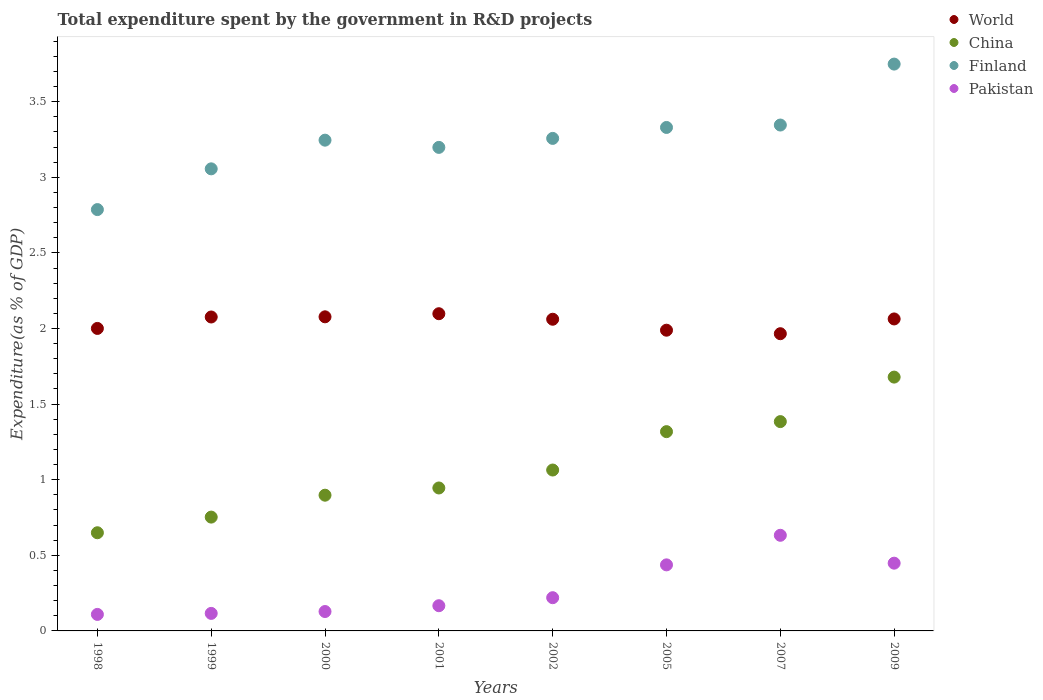How many different coloured dotlines are there?
Give a very brief answer. 4. Is the number of dotlines equal to the number of legend labels?
Provide a succinct answer. Yes. What is the total expenditure spent by the government in R&D projects in World in 2009?
Provide a short and direct response. 2.06. Across all years, what is the maximum total expenditure spent by the government in R&D projects in Pakistan?
Offer a terse response. 0.63. Across all years, what is the minimum total expenditure spent by the government in R&D projects in Pakistan?
Your answer should be very brief. 0.11. In which year was the total expenditure spent by the government in R&D projects in China maximum?
Offer a terse response. 2009. What is the total total expenditure spent by the government in R&D projects in Finland in the graph?
Provide a short and direct response. 25.97. What is the difference between the total expenditure spent by the government in R&D projects in Finland in 1999 and that in 2001?
Your answer should be very brief. -0.14. What is the difference between the total expenditure spent by the government in R&D projects in World in 1999 and the total expenditure spent by the government in R&D projects in Pakistan in 2005?
Offer a very short reply. 1.64. What is the average total expenditure spent by the government in R&D projects in Finland per year?
Provide a short and direct response. 3.25. In the year 2001, what is the difference between the total expenditure spent by the government in R&D projects in World and total expenditure spent by the government in R&D projects in China?
Your answer should be compact. 1.15. In how many years, is the total expenditure spent by the government in R&D projects in Pakistan greater than 0.1 %?
Keep it short and to the point. 8. What is the ratio of the total expenditure spent by the government in R&D projects in World in 2007 to that in 2009?
Your answer should be very brief. 0.95. What is the difference between the highest and the second highest total expenditure spent by the government in R&D projects in Finland?
Provide a succinct answer. 0.4. What is the difference between the highest and the lowest total expenditure spent by the government in R&D projects in Pakistan?
Offer a terse response. 0.52. In how many years, is the total expenditure spent by the government in R&D projects in Finland greater than the average total expenditure spent by the government in R&D projects in Finland taken over all years?
Offer a very short reply. 4. Is the sum of the total expenditure spent by the government in R&D projects in Pakistan in 1998 and 1999 greater than the maximum total expenditure spent by the government in R&D projects in Finland across all years?
Offer a very short reply. No. Is it the case that in every year, the sum of the total expenditure spent by the government in R&D projects in China and total expenditure spent by the government in R&D projects in Finland  is greater than the sum of total expenditure spent by the government in R&D projects in Pakistan and total expenditure spent by the government in R&D projects in World?
Keep it short and to the point. Yes. Is the total expenditure spent by the government in R&D projects in Finland strictly greater than the total expenditure spent by the government in R&D projects in World over the years?
Make the answer very short. Yes. Is the total expenditure spent by the government in R&D projects in World strictly less than the total expenditure spent by the government in R&D projects in China over the years?
Offer a very short reply. No. Are the values on the major ticks of Y-axis written in scientific E-notation?
Your response must be concise. No. Does the graph contain grids?
Your answer should be very brief. No. Where does the legend appear in the graph?
Your answer should be compact. Top right. How many legend labels are there?
Your response must be concise. 4. What is the title of the graph?
Offer a terse response. Total expenditure spent by the government in R&D projects. Does "Tunisia" appear as one of the legend labels in the graph?
Your answer should be compact. No. What is the label or title of the X-axis?
Offer a very short reply. Years. What is the label or title of the Y-axis?
Offer a very short reply. Expenditure(as % of GDP). What is the Expenditure(as % of GDP) of World in 1998?
Make the answer very short. 2. What is the Expenditure(as % of GDP) of China in 1998?
Your answer should be very brief. 0.65. What is the Expenditure(as % of GDP) in Finland in 1998?
Your answer should be compact. 2.79. What is the Expenditure(as % of GDP) of Pakistan in 1998?
Offer a very short reply. 0.11. What is the Expenditure(as % of GDP) in World in 1999?
Your answer should be very brief. 2.08. What is the Expenditure(as % of GDP) in China in 1999?
Your response must be concise. 0.75. What is the Expenditure(as % of GDP) of Finland in 1999?
Provide a short and direct response. 3.06. What is the Expenditure(as % of GDP) of Pakistan in 1999?
Provide a succinct answer. 0.12. What is the Expenditure(as % of GDP) of World in 2000?
Keep it short and to the point. 2.08. What is the Expenditure(as % of GDP) of China in 2000?
Keep it short and to the point. 0.9. What is the Expenditure(as % of GDP) of Finland in 2000?
Your answer should be very brief. 3.25. What is the Expenditure(as % of GDP) in Pakistan in 2000?
Ensure brevity in your answer.  0.13. What is the Expenditure(as % of GDP) in World in 2001?
Give a very brief answer. 2.1. What is the Expenditure(as % of GDP) in China in 2001?
Give a very brief answer. 0.95. What is the Expenditure(as % of GDP) in Finland in 2001?
Give a very brief answer. 3.2. What is the Expenditure(as % of GDP) in Pakistan in 2001?
Make the answer very short. 0.17. What is the Expenditure(as % of GDP) of World in 2002?
Keep it short and to the point. 2.06. What is the Expenditure(as % of GDP) in China in 2002?
Ensure brevity in your answer.  1.06. What is the Expenditure(as % of GDP) of Finland in 2002?
Ensure brevity in your answer.  3.26. What is the Expenditure(as % of GDP) of Pakistan in 2002?
Make the answer very short. 0.22. What is the Expenditure(as % of GDP) in World in 2005?
Provide a short and direct response. 1.99. What is the Expenditure(as % of GDP) of China in 2005?
Make the answer very short. 1.32. What is the Expenditure(as % of GDP) in Finland in 2005?
Ensure brevity in your answer.  3.33. What is the Expenditure(as % of GDP) in Pakistan in 2005?
Your answer should be very brief. 0.44. What is the Expenditure(as % of GDP) of World in 2007?
Your answer should be very brief. 1.97. What is the Expenditure(as % of GDP) in China in 2007?
Give a very brief answer. 1.38. What is the Expenditure(as % of GDP) of Finland in 2007?
Make the answer very short. 3.35. What is the Expenditure(as % of GDP) of Pakistan in 2007?
Offer a very short reply. 0.63. What is the Expenditure(as % of GDP) in World in 2009?
Offer a very short reply. 2.06. What is the Expenditure(as % of GDP) in China in 2009?
Offer a terse response. 1.68. What is the Expenditure(as % of GDP) in Finland in 2009?
Your answer should be compact. 3.75. What is the Expenditure(as % of GDP) in Pakistan in 2009?
Offer a very short reply. 0.45. Across all years, what is the maximum Expenditure(as % of GDP) in World?
Your response must be concise. 2.1. Across all years, what is the maximum Expenditure(as % of GDP) in China?
Make the answer very short. 1.68. Across all years, what is the maximum Expenditure(as % of GDP) in Finland?
Your answer should be compact. 3.75. Across all years, what is the maximum Expenditure(as % of GDP) of Pakistan?
Offer a very short reply. 0.63. Across all years, what is the minimum Expenditure(as % of GDP) in World?
Your answer should be very brief. 1.97. Across all years, what is the minimum Expenditure(as % of GDP) of China?
Make the answer very short. 0.65. Across all years, what is the minimum Expenditure(as % of GDP) in Finland?
Your response must be concise. 2.79. Across all years, what is the minimum Expenditure(as % of GDP) in Pakistan?
Provide a succinct answer. 0.11. What is the total Expenditure(as % of GDP) in World in the graph?
Your answer should be very brief. 16.33. What is the total Expenditure(as % of GDP) of China in the graph?
Give a very brief answer. 8.69. What is the total Expenditure(as % of GDP) of Finland in the graph?
Make the answer very short. 25.97. What is the total Expenditure(as % of GDP) in Pakistan in the graph?
Keep it short and to the point. 2.26. What is the difference between the Expenditure(as % of GDP) in World in 1998 and that in 1999?
Provide a short and direct response. -0.08. What is the difference between the Expenditure(as % of GDP) in China in 1998 and that in 1999?
Give a very brief answer. -0.1. What is the difference between the Expenditure(as % of GDP) in Finland in 1998 and that in 1999?
Make the answer very short. -0.27. What is the difference between the Expenditure(as % of GDP) in Pakistan in 1998 and that in 1999?
Your answer should be compact. -0.01. What is the difference between the Expenditure(as % of GDP) of World in 1998 and that in 2000?
Ensure brevity in your answer.  -0.08. What is the difference between the Expenditure(as % of GDP) of China in 1998 and that in 2000?
Provide a succinct answer. -0.25. What is the difference between the Expenditure(as % of GDP) of Finland in 1998 and that in 2000?
Your response must be concise. -0.46. What is the difference between the Expenditure(as % of GDP) in Pakistan in 1998 and that in 2000?
Give a very brief answer. -0.02. What is the difference between the Expenditure(as % of GDP) in World in 1998 and that in 2001?
Your answer should be very brief. -0.1. What is the difference between the Expenditure(as % of GDP) of China in 1998 and that in 2001?
Keep it short and to the point. -0.3. What is the difference between the Expenditure(as % of GDP) in Finland in 1998 and that in 2001?
Provide a succinct answer. -0.41. What is the difference between the Expenditure(as % of GDP) in Pakistan in 1998 and that in 2001?
Ensure brevity in your answer.  -0.06. What is the difference between the Expenditure(as % of GDP) of World in 1998 and that in 2002?
Your answer should be compact. -0.06. What is the difference between the Expenditure(as % of GDP) in China in 1998 and that in 2002?
Ensure brevity in your answer.  -0.41. What is the difference between the Expenditure(as % of GDP) in Finland in 1998 and that in 2002?
Make the answer very short. -0.47. What is the difference between the Expenditure(as % of GDP) in Pakistan in 1998 and that in 2002?
Offer a terse response. -0.11. What is the difference between the Expenditure(as % of GDP) in World in 1998 and that in 2005?
Your answer should be compact. 0.01. What is the difference between the Expenditure(as % of GDP) of China in 1998 and that in 2005?
Your answer should be very brief. -0.67. What is the difference between the Expenditure(as % of GDP) in Finland in 1998 and that in 2005?
Offer a terse response. -0.54. What is the difference between the Expenditure(as % of GDP) of Pakistan in 1998 and that in 2005?
Your answer should be compact. -0.33. What is the difference between the Expenditure(as % of GDP) in World in 1998 and that in 2007?
Provide a succinct answer. 0.03. What is the difference between the Expenditure(as % of GDP) of China in 1998 and that in 2007?
Provide a short and direct response. -0.74. What is the difference between the Expenditure(as % of GDP) of Finland in 1998 and that in 2007?
Your response must be concise. -0.56. What is the difference between the Expenditure(as % of GDP) of Pakistan in 1998 and that in 2007?
Your response must be concise. -0.52. What is the difference between the Expenditure(as % of GDP) in World in 1998 and that in 2009?
Give a very brief answer. -0.06. What is the difference between the Expenditure(as % of GDP) of China in 1998 and that in 2009?
Provide a succinct answer. -1.03. What is the difference between the Expenditure(as % of GDP) in Finland in 1998 and that in 2009?
Your answer should be very brief. -0.96. What is the difference between the Expenditure(as % of GDP) of Pakistan in 1998 and that in 2009?
Offer a terse response. -0.34. What is the difference between the Expenditure(as % of GDP) of World in 1999 and that in 2000?
Ensure brevity in your answer.  -0. What is the difference between the Expenditure(as % of GDP) in China in 1999 and that in 2000?
Your response must be concise. -0.14. What is the difference between the Expenditure(as % of GDP) in Finland in 1999 and that in 2000?
Make the answer very short. -0.19. What is the difference between the Expenditure(as % of GDP) in Pakistan in 1999 and that in 2000?
Keep it short and to the point. -0.01. What is the difference between the Expenditure(as % of GDP) in World in 1999 and that in 2001?
Ensure brevity in your answer.  -0.02. What is the difference between the Expenditure(as % of GDP) in China in 1999 and that in 2001?
Make the answer very short. -0.19. What is the difference between the Expenditure(as % of GDP) in Finland in 1999 and that in 2001?
Make the answer very short. -0.14. What is the difference between the Expenditure(as % of GDP) of Pakistan in 1999 and that in 2001?
Provide a succinct answer. -0.05. What is the difference between the Expenditure(as % of GDP) in World in 1999 and that in 2002?
Make the answer very short. 0.01. What is the difference between the Expenditure(as % of GDP) of China in 1999 and that in 2002?
Give a very brief answer. -0.31. What is the difference between the Expenditure(as % of GDP) in Finland in 1999 and that in 2002?
Give a very brief answer. -0.2. What is the difference between the Expenditure(as % of GDP) of Pakistan in 1999 and that in 2002?
Keep it short and to the point. -0.1. What is the difference between the Expenditure(as % of GDP) in World in 1999 and that in 2005?
Your answer should be very brief. 0.09. What is the difference between the Expenditure(as % of GDP) of China in 1999 and that in 2005?
Your answer should be compact. -0.57. What is the difference between the Expenditure(as % of GDP) in Finland in 1999 and that in 2005?
Provide a short and direct response. -0.27. What is the difference between the Expenditure(as % of GDP) in Pakistan in 1999 and that in 2005?
Ensure brevity in your answer.  -0.32. What is the difference between the Expenditure(as % of GDP) of World in 1999 and that in 2007?
Keep it short and to the point. 0.11. What is the difference between the Expenditure(as % of GDP) of China in 1999 and that in 2007?
Provide a short and direct response. -0.63. What is the difference between the Expenditure(as % of GDP) in Finland in 1999 and that in 2007?
Keep it short and to the point. -0.29. What is the difference between the Expenditure(as % of GDP) of Pakistan in 1999 and that in 2007?
Offer a very short reply. -0.52. What is the difference between the Expenditure(as % of GDP) in World in 1999 and that in 2009?
Offer a terse response. 0.01. What is the difference between the Expenditure(as % of GDP) in China in 1999 and that in 2009?
Your answer should be compact. -0.93. What is the difference between the Expenditure(as % of GDP) of Finland in 1999 and that in 2009?
Your answer should be very brief. -0.69. What is the difference between the Expenditure(as % of GDP) of Pakistan in 1999 and that in 2009?
Offer a very short reply. -0.33. What is the difference between the Expenditure(as % of GDP) in World in 2000 and that in 2001?
Offer a terse response. -0.02. What is the difference between the Expenditure(as % of GDP) of China in 2000 and that in 2001?
Your answer should be compact. -0.05. What is the difference between the Expenditure(as % of GDP) of Finland in 2000 and that in 2001?
Keep it short and to the point. 0.05. What is the difference between the Expenditure(as % of GDP) in Pakistan in 2000 and that in 2001?
Your answer should be compact. -0.04. What is the difference between the Expenditure(as % of GDP) in World in 2000 and that in 2002?
Keep it short and to the point. 0.02. What is the difference between the Expenditure(as % of GDP) of China in 2000 and that in 2002?
Offer a terse response. -0.17. What is the difference between the Expenditure(as % of GDP) in Finland in 2000 and that in 2002?
Keep it short and to the point. -0.01. What is the difference between the Expenditure(as % of GDP) of Pakistan in 2000 and that in 2002?
Your answer should be very brief. -0.09. What is the difference between the Expenditure(as % of GDP) in World in 2000 and that in 2005?
Ensure brevity in your answer.  0.09. What is the difference between the Expenditure(as % of GDP) in China in 2000 and that in 2005?
Give a very brief answer. -0.42. What is the difference between the Expenditure(as % of GDP) in Finland in 2000 and that in 2005?
Ensure brevity in your answer.  -0.08. What is the difference between the Expenditure(as % of GDP) of Pakistan in 2000 and that in 2005?
Your answer should be very brief. -0.31. What is the difference between the Expenditure(as % of GDP) in World in 2000 and that in 2007?
Offer a very short reply. 0.11. What is the difference between the Expenditure(as % of GDP) of China in 2000 and that in 2007?
Your answer should be very brief. -0.49. What is the difference between the Expenditure(as % of GDP) of Finland in 2000 and that in 2007?
Your answer should be very brief. -0.1. What is the difference between the Expenditure(as % of GDP) in Pakistan in 2000 and that in 2007?
Provide a succinct answer. -0.5. What is the difference between the Expenditure(as % of GDP) in World in 2000 and that in 2009?
Provide a short and direct response. 0.01. What is the difference between the Expenditure(as % of GDP) of China in 2000 and that in 2009?
Your answer should be very brief. -0.78. What is the difference between the Expenditure(as % of GDP) of Finland in 2000 and that in 2009?
Give a very brief answer. -0.5. What is the difference between the Expenditure(as % of GDP) in Pakistan in 2000 and that in 2009?
Your answer should be compact. -0.32. What is the difference between the Expenditure(as % of GDP) of World in 2001 and that in 2002?
Ensure brevity in your answer.  0.04. What is the difference between the Expenditure(as % of GDP) of China in 2001 and that in 2002?
Offer a very short reply. -0.12. What is the difference between the Expenditure(as % of GDP) of Finland in 2001 and that in 2002?
Offer a very short reply. -0.06. What is the difference between the Expenditure(as % of GDP) in Pakistan in 2001 and that in 2002?
Ensure brevity in your answer.  -0.05. What is the difference between the Expenditure(as % of GDP) of World in 2001 and that in 2005?
Ensure brevity in your answer.  0.11. What is the difference between the Expenditure(as % of GDP) in China in 2001 and that in 2005?
Keep it short and to the point. -0.37. What is the difference between the Expenditure(as % of GDP) in Finland in 2001 and that in 2005?
Your answer should be very brief. -0.13. What is the difference between the Expenditure(as % of GDP) in Pakistan in 2001 and that in 2005?
Provide a succinct answer. -0.27. What is the difference between the Expenditure(as % of GDP) of World in 2001 and that in 2007?
Your response must be concise. 0.13. What is the difference between the Expenditure(as % of GDP) in China in 2001 and that in 2007?
Offer a very short reply. -0.44. What is the difference between the Expenditure(as % of GDP) in Finland in 2001 and that in 2007?
Make the answer very short. -0.15. What is the difference between the Expenditure(as % of GDP) of Pakistan in 2001 and that in 2007?
Keep it short and to the point. -0.47. What is the difference between the Expenditure(as % of GDP) in World in 2001 and that in 2009?
Make the answer very short. 0.03. What is the difference between the Expenditure(as % of GDP) in China in 2001 and that in 2009?
Provide a short and direct response. -0.73. What is the difference between the Expenditure(as % of GDP) of Finland in 2001 and that in 2009?
Keep it short and to the point. -0.55. What is the difference between the Expenditure(as % of GDP) of Pakistan in 2001 and that in 2009?
Your answer should be very brief. -0.28. What is the difference between the Expenditure(as % of GDP) in World in 2002 and that in 2005?
Make the answer very short. 0.07. What is the difference between the Expenditure(as % of GDP) of China in 2002 and that in 2005?
Keep it short and to the point. -0.25. What is the difference between the Expenditure(as % of GDP) of Finland in 2002 and that in 2005?
Provide a short and direct response. -0.07. What is the difference between the Expenditure(as % of GDP) of Pakistan in 2002 and that in 2005?
Ensure brevity in your answer.  -0.22. What is the difference between the Expenditure(as % of GDP) of World in 2002 and that in 2007?
Your answer should be compact. 0.1. What is the difference between the Expenditure(as % of GDP) of China in 2002 and that in 2007?
Offer a very short reply. -0.32. What is the difference between the Expenditure(as % of GDP) in Finland in 2002 and that in 2007?
Offer a very short reply. -0.09. What is the difference between the Expenditure(as % of GDP) of Pakistan in 2002 and that in 2007?
Make the answer very short. -0.41. What is the difference between the Expenditure(as % of GDP) of World in 2002 and that in 2009?
Offer a very short reply. -0. What is the difference between the Expenditure(as % of GDP) of China in 2002 and that in 2009?
Your answer should be compact. -0.61. What is the difference between the Expenditure(as % of GDP) in Finland in 2002 and that in 2009?
Ensure brevity in your answer.  -0.49. What is the difference between the Expenditure(as % of GDP) in Pakistan in 2002 and that in 2009?
Offer a very short reply. -0.23. What is the difference between the Expenditure(as % of GDP) in World in 2005 and that in 2007?
Your answer should be compact. 0.02. What is the difference between the Expenditure(as % of GDP) of China in 2005 and that in 2007?
Keep it short and to the point. -0.07. What is the difference between the Expenditure(as % of GDP) in Finland in 2005 and that in 2007?
Ensure brevity in your answer.  -0.02. What is the difference between the Expenditure(as % of GDP) in Pakistan in 2005 and that in 2007?
Give a very brief answer. -0.2. What is the difference between the Expenditure(as % of GDP) of World in 2005 and that in 2009?
Give a very brief answer. -0.07. What is the difference between the Expenditure(as % of GDP) in China in 2005 and that in 2009?
Keep it short and to the point. -0.36. What is the difference between the Expenditure(as % of GDP) in Finland in 2005 and that in 2009?
Offer a terse response. -0.42. What is the difference between the Expenditure(as % of GDP) of Pakistan in 2005 and that in 2009?
Make the answer very short. -0.01. What is the difference between the Expenditure(as % of GDP) in World in 2007 and that in 2009?
Provide a short and direct response. -0.1. What is the difference between the Expenditure(as % of GDP) of China in 2007 and that in 2009?
Provide a short and direct response. -0.29. What is the difference between the Expenditure(as % of GDP) in Finland in 2007 and that in 2009?
Offer a very short reply. -0.4. What is the difference between the Expenditure(as % of GDP) of Pakistan in 2007 and that in 2009?
Give a very brief answer. 0.18. What is the difference between the Expenditure(as % of GDP) of World in 1998 and the Expenditure(as % of GDP) of China in 1999?
Provide a succinct answer. 1.25. What is the difference between the Expenditure(as % of GDP) of World in 1998 and the Expenditure(as % of GDP) of Finland in 1999?
Keep it short and to the point. -1.06. What is the difference between the Expenditure(as % of GDP) of World in 1998 and the Expenditure(as % of GDP) of Pakistan in 1999?
Provide a succinct answer. 1.88. What is the difference between the Expenditure(as % of GDP) of China in 1998 and the Expenditure(as % of GDP) of Finland in 1999?
Ensure brevity in your answer.  -2.41. What is the difference between the Expenditure(as % of GDP) of China in 1998 and the Expenditure(as % of GDP) of Pakistan in 1999?
Provide a short and direct response. 0.53. What is the difference between the Expenditure(as % of GDP) of Finland in 1998 and the Expenditure(as % of GDP) of Pakistan in 1999?
Make the answer very short. 2.67. What is the difference between the Expenditure(as % of GDP) in World in 1998 and the Expenditure(as % of GDP) in China in 2000?
Give a very brief answer. 1.1. What is the difference between the Expenditure(as % of GDP) in World in 1998 and the Expenditure(as % of GDP) in Finland in 2000?
Make the answer very short. -1.25. What is the difference between the Expenditure(as % of GDP) of World in 1998 and the Expenditure(as % of GDP) of Pakistan in 2000?
Your answer should be compact. 1.87. What is the difference between the Expenditure(as % of GDP) in China in 1998 and the Expenditure(as % of GDP) in Finland in 2000?
Keep it short and to the point. -2.6. What is the difference between the Expenditure(as % of GDP) of China in 1998 and the Expenditure(as % of GDP) of Pakistan in 2000?
Offer a terse response. 0.52. What is the difference between the Expenditure(as % of GDP) of Finland in 1998 and the Expenditure(as % of GDP) of Pakistan in 2000?
Ensure brevity in your answer.  2.66. What is the difference between the Expenditure(as % of GDP) of World in 1998 and the Expenditure(as % of GDP) of China in 2001?
Offer a very short reply. 1.06. What is the difference between the Expenditure(as % of GDP) in World in 1998 and the Expenditure(as % of GDP) in Finland in 2001?
Your response must be concise. -1.2. What is the difference between the Expenditure(as % of GDP) of World in 1998 and the Expenditure(as % of GDP) of Pakistan in 2001?
Offer a very short reply. 1.83. What is the difference between the Expenditure(as % of GDP) in China in 1998 and the Expenditure(as % of GDP) in Finland in 2001?
Your response must be concise. -2.55. What is the difference between the Expenditure(as % of GDP) of China in 1998 and the Expenditure(as % of GDP) of Pakistan in 2001?
Your answer should be very brief. 0.48. What is the difference between the Expenditure(as % of GDP) in Finland in 1998 and the Expenditure(as % of GDP) in Pakistan in 2001?
Your answer should be very brief. 2.62. What is the difference between the Expenditure(as % of GDP) of World in 1998 and the Expenditure(as % of GDP) of China in 2002?
Your answer should be very brief. 0.94. What is the difference between the Expenditure(as % of GDP) of World in 1998 and the Expenditure(as % of GDP) of Finland in 2002?
Your response must be concise. -1.26. What is the difference between the Expenditure(as % of GDP) of World in 1998 and the Expenditure(as % of GDP) of Pakistan in 2002?
Make the answer very short. 1.78. What is the difference between the Expenditure(as % of GDP) of China in 1998 and the Expenditure(as % of GDP) of Finland in 2002?
Keep it short and to the point. -2.61. What is the difference between the Expenditure(as % of GDP) of China in 1998 and the Expenditure(as % of GDP) of Pakistan in 2002?
Ensure brevity in your answer.  0.43. What is the difference between the Expenditure(as % of GDP) of Finland in 1998 and the Expenditure(as % of GDP) of Pakistan in 2002?
Offer a very short reply. 2.57. What is the difference between the Expenditure(as % of GDP) of World in 1998 and the Expenditure(as % of GDP) of China in 2005?
Your response must be concise. 0.68. What is the difference between the Expenditure(as % of GDP) of World in 1998 and the Expenditure(as % of GDP) of Finland in 2005?
Provide a succinct answer. -1.33. What is the difference between the Expenditure(as % of GDP) in World in 1998 and the Expenditure(as % of GDP) in Pakistan in 2005?
Your answer should be compact. 1.56. What is the difference between the Expenditure(as % of GDP) in China in 1998 and the Expenditure(as % of GDP) in Finland in 2005?
Make the answer very short. -2.68. What is the difference between the Expenditure(as % of GDP) in China in 1998 and the Expenditure(as % of GDP) in Pakistan in 2005?
Ensure brevity in your answer.  0.21. What is the difference between the Expenditure(as % of GDP) in Finland in 1998 and the Expenditure(as % of GDP) in Pakistan in 2005?
Your answer should be very brief. 2.35. What is the difference between the Expenditure(as % of GDP) in World in 1998 and the Expenditure(as % of GDP) in China in 2007?
Offer a terse response. 0.62. What is the difference between the Expenditure(as % of GDP) of World in 1998 and the Expenditure(as % of GDP) of Finland in 2007?
Your answer should be very brief. -1.35. What is the difference between the Expenditure(as % of GDP) in World in 1998 and the Expenditure(as % of GDP) in Pakistan in 2007?
Your answer should be compact. 1.37. What is the difference between the Expenditure(as % of GDP) of China in 1998 and the Expenditure(as % of GDP) of Finland in 2007?
Your answer should be compact. -2.7. What is the difference between the Expenditure(as % of GDP) in China in 1998 and the Expenditure(as % of GDP) in Pakistan in 2007?
Ensure brevity in your answer.  0.02. What is the difference between the Expenditure(as % of GDP) in Finland in 1998 and the Expenditure(as % of GDP) in Pakistan in 2007?
Offer a terse response. 2.15. What is the difference between the Expenditure(as % of GDP) in World in 1998 and the Expenditure(as % of GDP) in China in 2009?
Keep it short and to the point. 0.32. What is the difference between the Expenditure(as % of GDP) of World in 1998 and the Expenditure(as % of GDP) of Finland in 2009?
Provide a short and direct response. -1.75. What is the difference between the Expenditure(as % of GDP) of World in 1998 and the Expenditure(as % of GDP) of Pakistan in 2009?
Your answer should be compact. 1.55. What is the difference between the Expenditure(as % of GDP) in China in 1998 and the Expenditure(as % of GDP) in Finland in 2009?
Make the answer very short. -3.1. What is the difference between the Expenditure(as % of GDP) in China in 1998 and the Expenditure(as % of GDP) in Pakistan in 2009?
Provide a succinct answer. 0.2. What is the difference between the Expenditure(as % of GDP) of Finland in 1998 and the Expenditure(as % of GDP) of Pakistan in 2009?
Provide a succinct answer. 2.34. What is the difference between the Expenditure(as % of GDP) in World in 1999 and the Expenditure(as % of GDP) in China in 2000?
Ensure brevity in your answer.  1.18. What is the difference between the Expenditure(as % of GDP) in World in 1999 and the Expenditure(as % of GDP) in Finland in 2000?
Keep it short and to the point. -1.17. What is the difference between the Expenditure(as % of GDP) in World in 1999 and the Expenditure(as % of GDP) in Pakistan in 2000?
Your answer should be very brief. 1.95. What is the difference between the Expenditure(as % of GDP) in China in 1999 and the Expenditure(as % of GDP) in Finland in 2000?
Keep it short and to the point. -2.49. What is the difference between the Expenditure(as % of GDP) in China in 1999 and the Expenditure(as % of GDP) in Pakistan in 2000?
Provide a succinct answer. 0.62. What is the difference between the Expenditure(as % of GDP) in Finland in 1999 and the Expenditure(as % of GDP) in Pakistan in 2000?
Your answer should be compact. 2.93. What is the difference between the Expenditure(as % of GDP) of World in 1999 and the Expenditure(as % of GDP) of China in 2001?
Offer a terse response. 1.13. What is the difference between the Expenditure(as % of GDP) of World in 1999 and the Expenditure(as % of GDP) of Finland in 2001?
Offer a very short reply. -1.12. What is the difference between the Expenditure(as % of GDP) in World in 1999 and the Expenditure(as % of GDP) in Pakistan in 2001?
Provide a succinct answer. 1.91. What is the difference between the Expenditure(as % of GDP) of China in 1999 and the Expenditure(as % of GDP) of Finland in 2001?
Your response must be concise. -2.45. What is the difference between the Expenditure(as % of GDP) in China in 1999 and the Expenditure(as % of GDP) in Pakistan in 2001?
Your response must be concise. 0.59. What is the difference between the Expenditure(as % of GDP) of Finland in 1999 and the Expenditure(as % of GDP) of Pakistan in 2001?
Ensure brevity in your answer.  2.89. What is the difference between the Expenditure(as % of GDP) of World in 1999 and the Expenditure(as % of GDP) of China in 2002?
Offer a terse response. 1.01. What is the difference between the Expenditure(as % of GDP) in World in 1999 and the Expenditure(as % of GDP) in Finland in 2002?
Give a very brief answer. -1.18. What is the difference between the Expenditure(as % of GDP) in World in 1999 and the Expenditure(as % of GDP) in Pakistan in 2002?
Make the answer very short. 1.86. What is the difference between the Expenditure(as % of GDP) of China in 1999 and the Expenditure(as % of GDP) of Finland in 2002?
Provide a short and direct response. -2.5. What is the difference between the Expenditure(as % of GDP) of China in 1999 and the Expenditure(as % of GDP) of Pakistan in 2002?
Ensure brevity in your answer.  0.53. What is the difference between the Expenditure(as % of GDP) in Finland in 1999 and the Expenditure(as % of GDP) in Pakistan in 2002?
Give a very brief answer. 2.84. What is the difference between the Expenditure(as % of GDP) in World in 1999 and the Expenditure(as % of GDP) in China in 2005?
Your response must be concise. 0.76. What is the difference between the Expenditure(as % of GDP) in World in 1999 and the Expenditure(as % of GDP) in Finland in 2005?
Ensure brevity in your answer.  -1.25. What is the difference between the Expenditure(as % of GDP) of World in 1999 and the Expenditure(as % of GDP) of Pakistan in 2005?
Give a very brief answer. 1.64. What is the difference between the Expenditure(as % of GDP) in China in 1999 and the Expenditure(as % of GDP) in Finland in 2005?
Your response must be concise. -2.58. What is the difference between the Expenditure(as % of GDP) of China in 1999 and the Expenditure(as % of GDP) of Pakistan in 2005?
Ensure brevity in your answer.  0.32. What is the difference between the Expenditure(as % of GDP) of Finland in 1999 and the Expenditure(as % of GDP) of Pakistan in 2005?
Keep it short and to the point. 2.62. What is the difference between the Expenditure(as % of GDP) in World in 1999 and the Expenditure(as % of GDP) in China in 2007?
Provide a succinct answer. 0.69. What is the difference between the Expenditure(as % of GDP) in World in 1999 and the Expenditure(as % of GDP) in Finland in 2007?
Your answer should be very brief. -1.27. What is the difference between the Expenditure(as % of GDP) of World in 1999 and the Expenditure(as % of GDP) of Pakistan in 2007?
Make the answer very short. 1.44. What is the difference between the Expenditure(as % of GDP) in China in 1999 and the Expenditure(as % of GDP) in Finland in 2007?
Give a very brief answer. -2.59. What is the difference between the Expenditure(as % of GDP) of China in 1999 and the Expenditure(as % of GDP) of Pakistan in 2007?
Provide a short and direct response. 0.12. What is the difference between the Expenditure(as % of GDP) in Finland in 1999 and the Expenditure(as % of GDP) in Pakistan in 2007?
Offer a very short reply. 2.42. What is the difference between the Expenditure(as % of GDP) in World in 1999 and the Expenditure(as % of GDP) in China in 2009?
Give a very brief answer. 0.4. What is the difference between the Expenditure(as % of GDP) in World in 1999 and the Expenditure(as % of GDP) in Finland in 2009?
Offer a very short reply. -1.67. What is the difference between the Expenditure(as % of GDP) in World in 1999 and the Expenditure(as % of GDP) in Pakistan in 2009?
Ensure brevity in your answer.  1.63. What is the difference between the Expenditure(as % of GDP) in China in 1999 and the Expenditure(as % of GDP) in Finland in 2009?
Offer a terse response. -3. What is the difference between the Expenditure(as % of GDP) in China in 1999 and the Expenditure(as % of GDP) in Pakistan in 2009?
Make the answer very short. 0.3. What is the difference between the Expenditure(as % of GDP) in Finland in 1999 and the Expenditure(as % of GDP) in Pakistan in 2009?
Make the answer very short. 2.61. What is the difference between the Expenditure(as % of GDP) of World in 2000 and the Expenditure(as % of GDP) of China in 2001?
Give a very brief answer. 1.13. What is the difference between the Expenditure(as % of GDP) in World in 2000 and the Expenditure(as % of GDP) in Finland in 2001?
Offer a terse response. -1.12. What is the difference between the Expenditure(as % of GDP) in World in 2000 and the Expenditure(as % of GDP) in Pakistan in 2001?
Give a very brief answer. 1.91. What is the difference between the Expenditure(as % of GDP) in China in 2000 and the Expenditure(as % of GDP) in Finland in 2001?
Offer a very short reply. -2.3. What is the difference between the Expenditure(as % of GDP) of China in 2000 and the Expenditure(as % of GDP) of Pakistan in 2001?
Ensure brevity in your answer.  0.73. What is the difference between the Expenditure(as % of GDP) in Finland in 2000 and the Expenditure(as % of GDP) in Pakistan in 2001?
Your response must be concise. 3.08. What is the difference between the Expenditure(as % of GDP) of World in 2000 and the Expenditure(as % of GDP) of China in 2002?
Offer a very short reply. 1.01. What is the difference between the Expenditure(as % of GDP) in World in 2000 and the Expenditure(as % of GDP) in Finland in 2002?
Your response must be concise. -1.18. What is the difference between the Expenditure(as % of GDP) of World in 2000 and the Expenditure(as % of GDP) of Pakistan in 2002?
Offer a terse response. 1.86. What is the difference between the Expenditure(as % of GDP) of China in 2000 and the Expenditure(as % of GDP) of Finland in 2002?
Keep it short and to the point. -2.36. What is the difference between the Expenditure(as % of GDP) of China in 2000 and the Expenditure(as % of GDP) of Pakistan in 2002?
Your answer should be very brief. 0.68. What is the difference between the Expenditure(as % of GDP) of Finland in 2000 and the Expenditure(as % of GDP) of Pakistan in 2002?
Offer a very short reply. 3.03. What is the difference between the Expenditure(as % of GDP) in World in 2000 and the Expenditure(as % of GDP) in China in 2005?
Keep it short and to the point. 0.76. What is the difference between the Expenditure(as % of GDP) in World in 2000 and the Expenditure(as % of GDP) in Finland in 2005?
Provide a short and direct response. -1.25. What is the difference between the Expenditure(as % of GDP) in World in 2000 and the Expenditure(as % of GDP) in Pakistan in 2005?
Ensure brevity in your answer.  1.64. What is the difference between the Expenditure(as % of GDP) in China in 2000 and the Expenditure(as % of GDP) in Finland in 2005?
Provide a succinct answer. -2.43. What is the difference between the Expenditure(as % of GDP) in China in 2000 and the Expenditure(as % of GDP) in Pakistan in 2005?
Your answer should be very brief. 0.46. What is the difference between the Expenditure(as % of GDP) of Finland in 2000 and the Expenditure(as % of GDP) of Pakistan in 2005?
Your response must be concise. 2.81. What is the difference between the Expenditure(as % of GDP) of World in 2000 and the Expenditure(as % of GDP) of China in 2007?
Offer a terse response. 0.69. What is the difference between the Expenditure(as % of GDP) in World in 2000 and the Expenditure(as % of GDP) in Finland in 2007?
Your answer should be compact. -1.27. What is the difference between the Expenditure(as % of GDP) in World in 2000 and the Expenditure(as % of GDP) in Pakistan in 2007?
Your answer should be very brief. 1.44. What is the difference between the Expenditure(as % of GDP) in China in 2000 and the Expenditure(as % of GDP) in Finland in 2007?
Give a very brief answer. -2.45. What is the difference between the Expenditure(as % of GDP) of China in 2000 and the Expenditure(as % of GDP) of Pakistan in 2007?
Your response must be concise. 0.27. What is the difference between the Expenditure(as % of GDP) of Finland in 2000 and the Expenditure(as % of GDP) of Pakistan in 2007?
Offer a terse response. 2.61. What is the difference between the Expenditure(as % of GDP) of World in 2000 and the Expenditure(as % of GDP) of China in 2009?
Make the answer very short. 0.4. What is the difference between the Expenditure(as % of GDP) in World in 2000 and the Expenditure(as % of GDP) in Finland in 2009?
Keep it short and to the point. -1.67. What is the difference between the Expenditure(as % of GDP) of World in 2000 and the Expenditure(as % of GDP) of Pakistan in 2009?
Give a very brief answer. 1.63. What is the difference between the Expenditure(as % of GDP) in China in 2000 and the Expenditure(as % of GDP) in Finland in 2009?
Provide a succinct answer. -2.85. What is the difference between the Expenditure(as % of GDP) of China in 2000 and the Expenditure(as % of GDP) of Pakistan in 2009?
Offer a terse response. 0.45. What is the difference between the Expenditure(as % of GDP) of Finland in 2000 and the Expenditure(as % of GDP) of Pakistan in 2009?
Ensure brevity in your answer.  2.8. What is the difference between the Expenditure(as % of GDP) in World in 2001 and the Expenditure(as % of GDP) in China in 2002?
Offer a very short reply. 1.03. What is the difference between the Expenditure(as % of GDP) in World in 2001 and the Expenditure(as % of GDP) in Finland in 2002?
Keep it short and to the point. -1.16. What is the difference between the Expenditure(as % of GDP) of World in 2001 and the Expenditure(as % of GDP) of Pakistan in 2002?
Your answer should be very brief. 1.88. What is the difference between the Expenditure(as % of GDP) in China in 2001 and the Expenditure(as % of GDP) in Finland in 2002?
Your response must be concise. -2.31. What is the difference between the Expenditure(as % of GDP) in China in 2001 and the Expenditure(as % of GDP) in Pakistan in 2002?
Your answer should be very brief. 0.73. What is the difference between the Expenditure(as % of GDP) of Finland in 2001 and the Expenditure(as % of GDP) of Pakistan in 2002?
Your response must be concise. 2.98. What is the difference between the Expenditure(as % of GDP) in World in 2001 and the Expenditure(as % of GDP) in China in 2005?
Ensure brevity in your answer.  0.78. What is the difference between the Expenditure(as % of GDP) of World in 2001 and the Expenditure(as % of GDP) of Finland in 2005?
Offer a terse response. -1.23. What is the difference between the Expenditure(as % of GDP) of World in 2001 and the Expenditure(as % of GDP) of Pakistan in 2005?
Your answer should be compact. 1.66. What is the difference between the Expenditure(as % of GDP) in China in 2001 and the Expenditure(as % of GDP) in Finland in 2005?
Offer a very short reply. -2.38. What is the difference between the Expenditure(as % of GDP) of China in 2001 and the Expenditure(as % of GDP) of Pakistan in 2005?
Your response must be concise. 0.51. What is the difference between the Expenditure(as % of GDP) in Finland in 2001 and the Expenditure(as % of GDP) in Pakistan in 2005?
Make the answer very short. 2.76. What is the difference between the Expenditure(as % of GDP) of World in 2001 and the Expenditure(as % of GDP) of China in 2007?
Offer a very short reply. 0.71. What is the difference between the Expenditure(as % of GDP) of World in 2001 and the Expenditure(as % of GDP) of Finland in 2007?
Your response must be concise. -1.25. What is the difference between the Expenditure(as % of GDP) in World in 2001 and the Expenditure(as % of GDP) in Pakistan in 2007?
Keep it short and to the point. 1.47. What is the difference between the Expenditure(as % of GDP) in China in 2001 and the Expenditure(as % of GDP) in Finland in 2007?
Make the answer very short. -2.4. What is the difference between the Expenditure(as % of GDP) in China in 2001 and the Expenditure(as % of GDP) in Pakistan in 2007?
Your response must be concise. 0.31. What is the difference between the Expenditure(as % of GDP) in Finland in 2001 and the Expenditure(as % of GDP) in Pakistan in 2007?
Your answer should be very brief. 2.57. What is the difference between the Expenditure(as % of GDP) in World in 2001 and the Expenditure(as % of GDP) in China in 2009?
Make the answer very short. 0.42. What is the difference between the Expenditure(as % of GDP) in World in 2001 and the Expenditure(as % of GDP) in Finland in 2009?
Your answer should be very brief. -1.65. What is the difference between the Expenditure(as % of GDP) of World in 2001 and the Expenditure(as % of GDP) of Pakistan in 2009?
Give a very brief answer. 1.65. What is the difference between the Expenditure(as % of GDP) in China in 2001 and the Expenditure(as % of GDP) in Finland in 2009?
Ensure brevity in your answer.  -2.8. What is the difference between the Expenditure(as % of GDP) of China in 2001 and the Expenditure(as % of GDP) of Pakistan in 2009?
Make the answer very short. 0.5. What is the difference between the Expenditure(as % of GDP) of Finland in 2001 and the Expenditure(as % of GDP) of Pakistan in 2009?
Provide a short and direct response. 2.75. What is the difference between the Expenditure(as % of GDP) of World in 2002 and the Expenditure(as % of GDP) of China in 2005?
Provide a succinct answer. 0.74. What is the difference between the Expenditure(as % of GDP) in World in 2002 and the Expenditure(as % of GDP) in Finland in 2005?
Your answer should be very brief. -1.27. What is the difference between the Expenditure(as % of GDP) in World in 2002 and the Expenditure(as % of GDP) in Pakistan in 2005?
Ensure brevity in your answer.  1.62. What is the difference between the Expenditure(as % of GDP) in China in 2002 and the Expenditure(as % of GDP) in Finland in 2005?
Give a very brief answer. -2.27. What is the difference between the Expenditure(as % of GDP) of China in 2002 and the Expenditure(as % of GDP) of Pakistan in 2005?
Provide a succinct answer. 0.63. What is the difference between the Expenditure(as % of GDP) of Finland in 2002 and the Expenditure(as % of GDP) of Pakistan in 2005?
Offer a very short reply. 2.82. What is the difference between the Expenditure(as % of GDP) in World in 2002 and the Expenditure(as % of GDP) in China in 2007?
Offer a terse response. 0.68. What is the difference between the Expenditure(as % of GDP) in World in 2002 and the Expenditure(as % of GDP) in Finland in 2007?
Ensure brevity in your answer.  -1.28. What is the difference between the Expenditure(as % of GDP) in World in 2002 and the Expenditure(as % of GDP) in Pakistan in 2007?
Offer a terse response. 1.43. What is the difference between the Expenditure(as % of GDP) in China in 2002 and the Expenditure(as % of GDP) in Finland in 2007?
Your answer should be very brief. -2.28. What is the difference between the Expenditure(as % of GDP) in China in 2002 and the Expenditure(as % of GDP) in Pakistan in 2007?
Ensure brevity in your answer.  0.43. What is the difference between the Expenditure(as % of GDP) of Finland in 2002 and the Expenditure(as % of GDP) of Pakistan in 2007?
Keep it short and to the point. 2.62. What is the difference between the Expenditure(as % of GDP) of World in 2002 and the Expenditure(as % of GDP) of China in 2009?
Give a very brief answer. 0.38. What is the difference between the Expenditure(as % of GDP) of World in 2002 and the Expenditure(as % of GDP) of Finland in 2009?
Offer a terse response. -1.69. What is the difference between the Expenditure(as % of GDP) in World in 2002 and the Expenditure(as % of GDP) in Pakistan in 2009?
Ensure brevity in your answer.  1.61. What is the difference between the Expenditure(as % of GDP) in China in 2002 and the Expenditure(as % of GDP) in Finland in 2009?
Provide a succinct answer. -2.68. What is the difference between the Expenditure(as % of GDP) in China in 2002 and the Expenditure(as % of GDP) in Pakistan in 2009?
Offer a terse response. 0.62. What is the difference between the Expenditure(as % of GDP) in Finland in 2002 and the Expenditure(as % of GDP) in Pakistan in 2009?
Provide a succinct answer. 2.81. What is the difference between the Expenditure(as % of GDP) in World in 2005 and the Expenditure(as % of GDP) in China in 2007?
Give a very brief answer. 0.6. What is the difference between the Expenditure(as % of GDP) in World in 2005 and the Expenditure(as % of GDP) in Finland in 2007?
Your answer should be compact. -1.36. What is the difference between the Expenditure(as % of GDP) in World in 2005 and the Expenditure(as % of GDP) in Pakistan in 2007?
Make the answer very short. 1.36. What is the difference between the Expenditure(as % of GDP) of China in 2005 and the Expenditure(as % of GDP) of Finland in 2007?
Offer a terse response. -2.03. What is the difference between the Expenditure(as % of GDP) of China in 2005 and the Expenditure(as % of GDP) of Pakistan in 2007?
Offer a very short reply. 0.69. What is the difference between the Expenditure(as % of GDP) of Finland in 2005 and the Expenditure(as % of GDP) of Pakistan in 2007?
Ensure brevity in your answer.  2.7. What is the difference between the Expenditure(as % of GDP) of World in 2005 and the Expenditure(as % of GDP) of China in 2009?
Give a very brief answer. 0.31. What is the difference between the Expenditure(as % of GDP) of World in 2005 and the Expenditure(as % of GDP) of Finland in 2009?
Give a very brief answer. -1.76. What is the difference between the Expenditure(as % of GDP) of World in 2005 and the Expenditure(as % of GDP) of Pakistan in 2009?
Provide a short and direct response. 1.54. What is the difference between the Expenditure(as % of GDP) in China in 2005 and the Expenditure(as % of GDP) in Finland in 2009?
Provide a short and direct response. -2.43. What is the difference between the Expenditure(as % of GDP) in China in 2005 and the Expenditure(as % of GDP) in Pakistan in 2009?
Give a very brief answer. 0.87. What is the difference between the Expenditure(as % of GDP) of Finland in 2005 and the Expenditure(as % of GDP) of Pakistan in 2009?
Offer a terse response. 2.88. What is the difference between the Expenditure(as % of GDP) in World in 2007 and the Expenditure(as % of GDP) in China in 2009?
Give a very brief answer. 0.29. What is the difference between the Expenditure(as % of GDP) in World in 2007 and the Expenditure(as % of GDP) in Finland in 2009?
Provide a succinct answer. -1.78. What is the difference between the Expenditure(as % of GDP) in World in 2007 and the Expenditure(as % of GDP) in Pakistan in 2009?
Offer a terse response. 1.52. What is the difference between the Expenditure(as % of GDP) of China in 2007 and the Expenditure(as % of GDP) of Finland in 2009?
Offer a terse response. -2.36. What is the difference between the Expenditure(as % of GDP) in China in 2007 and the Expenditure(as % of GDP) in Pakistan in 2009?
Give a very brief answer. 0.94. What is the difference between the Expenditure(as % of GDP) in Finland in 2007 and the Expenditure(as % of GDP) in Pakistan in 2009?
Make the answer very short. 2.9. What is the average Expenditure(as % of GDP) of World per year?
Your answer should be very brief. 2.04. What is the average Expenditure(as % of GDP) in China per year?
Ensure brevity in your answer.  1.09. What is the average Expenditure(as % of GDP) of Finland per year?
Give a very brief answer. 3.25. What is the average Expenditure(as % of GDP) in Pakistan per year?
Give a very brief answer. 0.28. In the year 1998, what is the difference between the Expenditure(as % of GDP) in World and Expenditure(as % of GDP) in China?
Your response must be concise. 1.35. In the year 1998, what is the difference between the Expenditure(as % of GDP) in World and Expenditure(as % of GDP) in Finland?
Give a very brief answer. -0.79. In the year 1998, what is the difference between the Expenditure(as % of GDP) in World and Expenditure(as % of GDP) in Pakistan?
Your answer should be very brief. 1.89. In the year 1998, what is the difference between the Expenditure(as % of GDP) of China and Expenditure(as % of GDP) of Finland?
Ensure brevity in your answer.  -2.14. In the year 1998, what is the difference between the Expenditure(as % of GDP) in China and Expenditure(as % of GDP) in Pakistan?
Keep it short and to the point. 0.54. In the year 1998, what is the difference between the Expenditure(as % of GDP) in Finland and Expenditure(as % of GDP) in Pakistan?
Keep it short and to the point. 2.68. In the year 1999, what is the difference between the Expenditure(as % of GDP) in World and Expenditure(as % of GDP) in China?
Offer a very short reply. 1.32. In the year 1999, what is the difference between the Expenditure(as % of GDP) in World and Expenditure(as % of GDP) in Finland?
Provide a succinct answer. -0.98. In the year 1999, what is the difference between the Expenditure(as % of GDP) in World and Expenditure(as % of GDP) in Pakistan?
Your answer should be very brief. 1.96. In the year 1999, what is the difference between the Expenditure(as % of GDP) of China and Expenditure(as % of GDP) of Finland?
Your answer should be very brief. -2.3. In the year 1999, what is the difference between the Expenditure(as % of GDP) in China and Expenditure(as % of GDP) in Pakistan?
Offer a terse response. 0.64. In the year 1999, what is the difference between the Expenditure(as % of GDP) of Finland and Expenditure(as % of GDP) of Pakistan?
Your response must be concise. 2.94. In the year 2000, what is the difference between the Expenditure(as % of GDP) in World and Expenditure(as % of GDP) in China?
Offer a terse response. 1.18. In the year 2000, what is the difference between the Expenditure(as % of GDP) in World and Expenditure(as % of GDP) in Finland?
Your answer should be very brief. -1.17. In the year 2000, what is the difference between the Expenditure(as % of GDP) of World and Expenditure(as % of GDP) of Pakistan?
Offer a very short reply. 1.95. In the year 2000, what is the difference between the Expenditure(as % of GDP) of China and Expenditure(as % of GDP) of Finland?
Give a very brief answer. -2.35. In the year 2000, what is the difference between the Expenditure(as % of GDP) of China and Expenditure(as % of GDP) of Pakistan?
Keep it short and to the point. 0.77. In the year 2000, what is the difference between the Expenditure(as % of GDP) of Finland and Expenditure(as % of GDP) of Pakistan?
Provide a succinct answer. 3.12. In the year 2001, what is the difference between the Expenditure(as % of GDP) in World and Expenditure(as % of GDP) in China?
Your response must be concise. 1.15. In the year 2001, what is the difference between the Expenditure(as % of GDP) in World and Expenditure(as % of GDP) in Finland?
Make the answer very short. -1.1. In the year 2001, what is the difference between the Expenditure(as % of GDP) in World and Expenditure(as % of GDP) in Pakistan?
Offer a very short reply. 1.93. In the year 2001, what is the difference between the Expenditure(as % of GDP) of China and Expenditure(as % of GDP) of Finland?
Make the answer very short. -2.25. In the year 2001, what is the difference between the Expenditure(as % of GDP) of China and Expenditure(as % of GDP) of Pakistan?
Your response must be concise. 0.78. In the year 2001, what is the difference between the Expenditure(as % of GDP) in Finland and Expenditure(as % of GDP) in Pakistan?
Give a very brief answer. 3.03. In the year 2002, what is the difference between the Expenditure(as % of GDP) in World and Expenditure(as % of GDP) in Finland?
Make the answer very short. -1.2. In the year 2002, what is the difference between the Expenditure(as % of GDP) in World and Expenditure(as % of GDP) in Pakistan?
Offer a very short reply. 1.84. In the year 2002, what is the difference between the Expenditure(as % of GDP) in China and Expenditure(as % of GDP) in Finland?
Your answer should be compact. -2.19. In the year 2002, what is the difference between the Expenditure(as % of GDP) of China and Expenditure(as % of GDP) of Pakistan?
Offer a very short reply. 0.84. In the year 2002, what is the difference between the Expenditure(as % of GDP) of Finland and Expenditure(as % of GDP) of Pakistan?
Offer a terse response. 3.04. In the year 2005, what is the difference between the Expenditure(as % of GDP) of World and Expenditure(as % of GDP) of China?
Ensure brevity in your answer.  0.67. In the year 2005, what is the difference between the Expenditure(as % of GDP) in World and Expenditure(as % of GDP) in Finland?
Provide a short and direct response. -1.34. In the year 2005, what is the difference between the Expenditure(as % of GDP) of World and Expenditure(as % of GDP) of Pakistan?
Offer a terse response. 1.55. In the year 2005, what is the difference between the Expenditure(as % of GDP) in China and Expenditure(as % of GDP) in Finland?
Offer a very short reply. -2.01. In the year 2005, what is the difference between the Expenditure(as % of GDP) of China and Expenditure(as % of GDP) of Pakistan?
Provide a succinct answer. 0.88. In the year 2005, what is the difference between the Expenditure(as % of GDP) in Finland and Expenditure(as % of GDP) in Pakistan?
Make the answer very short. 2.89. In the year 2007, what is the difference between the Expenditure(as % of GDP) in World and Expenditure(as % of GDP) in China?
Your answer should be compact. 0.58. In the year 2007, what is the difference between the Expenditure(as % of GDP) in World and Expenditure(as % of GDP) in Finland?
Your answer should be compact. -1.38. In the year 2007, what is the difference between the Expenditure(as % of GDP) of World and Expenditure(as % of GDP) of Pakistan?
Offer a terse response. 1.33. In the year 2007, what is the difference between the Expenditure(as % of GDP) in China and Expenditure(as % of GDP) in Finland?
Provide a succinct answer. -1.96. In the year 2007, what is the difference between the Expenditure(as % of GDP) of China and Expenditure(as % of GDP) of Pakistan?
Ensure brevity in your answer.  0.75. In the year 2007, what is the difference between the Expenditure(as % of GDP) in Finland and Expenditure(as % of GDP) in Pakistan?
Make the answer very short. 2.71. In the year 2009, what is the difference between the Expenditure(as % of GDP) of World and Expenditure(as % of GDP) of China?
Keep it short and to the point. 0.38. In the year 2009, what is the difference between the Expenditure(as % of GDP) in World and Expenditure(as % of GDP) in Finland?
Provide a short and direct response. -1.69. In the year 2009, what is the difference between the Expenditure(as % of GDP) in World and Expenditure(as % of GDP) in Pakistan?
Offer a terse response. 1.62. In the year 2009, what is the difference between the Expenditure(as % of GDP) in China and Expenditure(as % of GDP) in Finland?
Give a very brief answer. -2.07. In the year 2009, what is the difference between the Expenditure(as % of GDP) of China and Expenditure(as % of GDP) of Pakistan?
Offer a very short reply. 1.23. In the year 2009, what is the difference between the Expenditure(as % of GDP) in Finland and Expenditure(as % of GDP) in Pakistan?
Provide a short and direct response. 3.3. What is the ratio of the Expenditure(as % of GDP) of World in 1998 to that in 1999?
Provide a short and direct response. 0.96. What is the ratio of the Expenditure(as % of GDP) in China in 1998 to that in 1999?
Provide a short and direct response. 0.86. What is the ratio of the Expenditure(as % of GDP) of Finland in 1998 to that in 1999?
Keep it short and to the point. 0.91. What is the ratio of the Expenditure(as % of GDP) of Pakistan in 1998 to that in 1999?
Ensure brevity in your answer.  0.94. What is the ratio of the Expenditure(as % of GDP) of China in 1998 to that in 2000?
Give a very brief answer. 0.72. What is the ratio of the Expenditure(as % of GDP) of Finland in 1998 to that in 2000?
Your answer should be compact. 0.86. What is the ratio of the Expenditure(as % of GDP) of Pakistan in 1998 to that in 2000?
Your answer should be compact. 0.85. What is the ratio of the Expenditure(as % of GDP) in World in 1998 to that in 2001?
Offer a very short reply. 0.95. What is the ratio of the Expenditure(as % of GDP) in China in 1998 to that in 2001?
Ensure brevity in your answer.  0.69. What is the ratio of the Expenditure(as % of GDP) in Finland in 1998 to that in 2001?
Offer a terse response. 0.87. What is the ratio of the Expenditure(as % of GDP) of Pakistan in 1998 to that in 2001?
Keep it short and to the point. 0.66. What is the ratio of the Expenditure(as % of GDP) of World in 1998 to that in 2002?
Your response must be concise. 0.97. What is the ratio of the Expenditure(as % of GDP) in China in 1998 to that in 2002?
Offer a terse response. 0.61. What is the ratio of the Expenditure(as % of GDP) in Finland in 1998 to that in 2002?
Your answer should be compact. 0.86. What is the ratio of the Expenditure(as % of GDP) of Pakistan in 1998 to that in 2002?
Provide a succinct answer. 0.5. What is the ratio of the Expenditure(as % of GDP) of World in 1998 to that in 2005?
Offer a terse response. 1.01. What is the ratio of the Expenditure(as % of GDP) in China in 1998 to that in 2005?
Provide a short and direct response. 0.49. What is the ratio of the Expenditure(as % of GDP) in Finland in 1998 to that in 2005?
Provide a short and direct response. 0.84. What is the ratio of the Expenditure(as % of GDP) in Pakistan in 1998 to that in 2005?
Your answer should be compact. 0.25. What is the ratio of the Expenditure(as % of GDP) in World in 1998 to that in 2007?
Offer a terse response. 1.02. What is the ratio of the Expenditure(as % of GDP) in China in 1998 to that in 2007?
Offer a very short reply. 0.47. What is the ratio of the Expenditure(as % of GDP) of Finland in 1998 to that in 2007?
Offer a terse response. 0.83. What is the ratio of the Expenditure(as % of GDP) of Pakistan in 1998 to that in 2007?
Your answer should be compact. 0.17. What is the ratio of the Expenditure(as % of GDP) of World in 1998 to that in 2009?
Your answer should be compact. 0.97. What is the ratio of the Expenditure(as % of GDP) in China in 1998 to that in 2009?
Provide a succinct answer. 0.39. What is the ratio of the Expenditure(as % of GDP) in Finland in 1998 to that in 2009?
Offer a very short reply. 0.74. What is the ratio of the Expenditure(as % of GDP) of Pakistan in 1998 to that in 2009?
Provide a short and direct response. 0.24. What is the ratio of the Expenditure(as % of GDP) in World in 1999 to that in 2000?
Give a very brief answer. 1. What is the ratio of the Expenditure(as % of GDP) of China in 1999 to that in 2000?
Make the answer very short. 0.84. What is the ratio of the Expenditure(as % of GDP) in Finland in 1999 to that in 2000?
Offer a terse response. 0.94. What is the ratio of the Expenditure(as % of GDP) in Pakistan in 1999 to that in 2000?
Offer a terse response. 0.9. What is the ratio of the Expenditure(as % of GDP) in China in 1999 to that in 2001?
Your answer should be very brief. 0.8. What is the ratio of the Expenditure(as % of GDP) in Finland in 1999 to that in 2001?
Keep it short and to the point. 0.96. What is the ratio of the Expenditure(as % of GDP) in Pakistan in 1999 to that in 2001?
Keep it short and to the point. 0.7. What is the ratio of the Expenditure(as % of GDP) in World in 1999 to that in 2002?
Offer a very short reply. 1.01. What is the ratio of the Expenditure(as % of GDP) of China in 1999 to that in 2002?
Offer a very short reply. 0.71. What is the ratio of the Expenditure(as % of GDP) in Finland in 1999 to that in 2002?
Provide a succinct answer. 0.94. What is the ratio of the Expenditure(as % of GDP) in Pakistan in 1999 to that in 2002?
Your answer should be very brief. 0.53. What is the ratio of the Expenditure(as % of GDP) in World in 1999 to that in 2005?
Your response must be concise. 1.04. What is the ratio of the Expenditure(as % of GDP) of China in 1999 to that in 2005?
Your response must be concise. 0.57. What is the ratio of the Expenditure(as % of GDP) of Finland in 1999 to that in 2005?
Offer a terse response. 0.92. What is the ratio of the Expenditure(as % of GDP) in Pakistan in 1999 to that in 2005?
Give a very brief answer. 0.27. What is the ratio of the Expenditure(as % of GDP) of World in 1999 to that in 2007?
Provide a short and direct response. 1.06. What is the ratio of the Expenditure(as % of GDP) in China in 1999 to that in 2007?
Your answer should be compact. 0.54. What is the ratio of the Expenditure(as % of GDP) in Finland in 1999 to that in 2007?
Offer a terse response. 0.91. What is the ratio of the Expenditure(as % of GDP) of Pakistan in 1999 to that in 2007?
Ensure brevity in your answer.  0.18. What is the ratio of the Expenditure(as % of GDP) in World in 1999 to that in 2009?
Make the answer very short. 1.01. What is the ratio of the Expenditure(as % of GDP) of China in 1999 to that in 2009?
Provide a succinct answer. 0.45. What is the ratio of the Expenditure(as % of GDP) in Finland in 1999 to that in 2009?
Offer a terse response. 0.82. What is the ratio of the Expenditure(as % of GDP) in Pakistan in 1999 to that in 2009?
Offer a very short reply. 0.26. What is the ratio of the Expenditure(as % of GDP) in World in 2000 to that in 2001?
Offer a terse response. 0.99. What is the ratio of the Expenditure(as % of GDP) in China in 2000 to that in 2001?
Ensure brevity in your answer.  0.95. What is the ratio of the Expenditure(as % of GDP) in Finland in 2000 to that in 2001?
Your answer should be very brief. 1.01. What is the ratio of the Expenditure(as % of GDP) in Pakistan in 2000 to that in 2001?
Provide a short and direct response. 0.77. What is the ratio of the Expenditure(as % of GDP) of World in 2000 to that in 2002?
Keep it short and to the point. 1.01. What is the ratio of the Expenditure(as % of GDP) in China in 2000 to that in 2002?
Your answer should be very brief. 0.84. What is the ratio of the Expenditure(as % of GDP) in Pakistan in 2000 to that in 2002?
Offer a very short reply. 0.58. What is the ratio of the Expenditure(as % of GDP) in World in 2000 to that in 2005?
Offer a very short reply. 1.04. What is the ratio of the Expenditure(as % of GDP) of China in 2000 to that in 2005?
Ensure brevity in your answer.  0.68. What is the ratio of the Expenditure(as % of GDP) in Finland in 2000 to that in 2005?
Offer a very short reply. 0.97. What is the ratio of the Expenditure(as % of GDP) of Pakistan in 2000 to that in 2005?
Keep it short and to the point. 0.29. What is the ratio of the Expenditure(as % of GDP) in World in 2000 to that in 2007?
Give a very brief answer. 1.06. What is the ratio of the Expenditure(as % of GDP) in China in 2000 to that in 2007?
Your response must be concise. 0.65. What is the ratio of the Expenditure(as % of GDP) in Finland in 2000 to that in 2007?
Offer a very short reply. 0.97. What is the ratio of the Expenditure(as % of GDP) in Pakistan in 2000 to that in 2007?
Make the answer very short. 0.2. What is the ratio of the Expenditure(as % of GDP) in World in 2000 to that in 2009?
Your answer should be compact. 1.01. What is the ratio of the Expenditure(as % of GDP) of China in 2000 to that in 2009?
Make the answer very short. 0.53. What is the ratio of the Expenditure(as % of GDP) in Finland in 2000 to that in 2009?
Provide a succinct answer. 0.87. What is the ratio of the Expenditure(as % of GDP) in Pakistan in 2000 to that in 2009?
Offer a very short reply. 0.29. What is the ratio of the Expenditure(as % of GDP) in World in 2001 to that in 2002?
Your answer should be very brief. 1.02. What is the ratio of the Expenditure(as % of GDP) of China in 2001 to that in 2002?
Ensure brevity in your answer.  0.89. What is the ratio of the Expenditure(as % of GDP) in Finland in 2001 to that in 2002?
Your answer should be compact. 0.98. What is the ratio of the Expenditure(as % of GDP) of Pakistan in 2001 to that in 2002?
Offer a terse response. 0.76. What is the ratio of the Expenditure(as % of GDP) in World in 2001 to that in 2005?
Your answer should be compact. 1.05. What is the ratio of the Expenditure(as % of GDP) in China in 2001 to that in 2005?
Give a very brief answer. 0.72. What is the ratio of the Expenditure(as % of GDP) of Finland in 2001 to that in 2005?
Keep it short and to the point. 0.96. What is the ratio of the Expenditure(as % of GDP) in Pakistan in 2001 to that in 2005?
Provide a short and direct response. 0.38. What is the ratio of the Expenditure(as % of GDP) in World in 2001 to that in 2007?
Your response must be concise. 1.07. What is the ratio of the Expenditure(as % of GDP) in China in 2001 to that in 2007?
Your answer should be compact. 0.68. What is the ratio of the Expenditure(as % of GDP) in Finland in 2001 to that in 2007?
Your answer should be compact. 0.96. What is the ratio of the Expenditure(as % of GDP) of Pakistan in 2001 to that in 2007?
Your answer should be compact. 0.26. What is the ratio of the Expenditure(as % of GDP) of World in 2001 to that in 2009?
Keep it short and to the point. 1.02. What is the ratio of the Expenditure(as % of GDP) of China in 2001 to that in 2009?
Keep it short and to the point. 0.56. What is the ratio of the Expenditure(as % of GDP) of Finland in 2001 to that in 2009?
Offer a terse response. 0.85. What is the ratio of the Expenditure(as % of GDP) of Pakistan in 2001 to that in 2009?
Ensure brevity in your answer.  0.37. What is the ratio of the Expenditure(as % of GDP) of World in 2002 to that in 2005?
Offer a terse response. 1.04. What is the ratio of the Expenditure(as % of GDP) of China in 2002 to that in 2005?
Ensure brevity in your answer.  0.81. What is the ratio of the Expenditure(as % of GDP) of Finland in 2002 to that in 2005?
Make the answer very short. 0.98. What is the ratio of the Expenditure(as % of GDP) in Pakistan in 2002 to that in 2005?
Give a very brief answer. 0.5. What is the ratio of the Expenditure(as % of GDP) in World in 2002 to that in 2007?
Your answer should be compact. 1.05. What is the ratio of the Expenditure(as % of GDP) of China in 2002 to that in 2007?
Ensure brevity in your answer.  0.77. What is the ratio of the Expenditure(as % of GDP) in Finland in 2002 to that in 2007?
Make the answer very short. 0.97. What is the ratio of the Expenditure(as % of GDP) in Pakistan in 2002 to that in 2007?
Provide a succinct answer. 0.35. What is the ratio of the Expenditure(as % of GDP) of World in 2002 to that in 2009?
Give a very brief answer. 1. What is the ratio of the Expenditure(as % of GDP) in China in 2002 to that in 2009?
Your answer should be very brief. 0.63. What is the ratio of the Expenditure(as % of GDP) of Finland in 2002 to that in 2009?
Ensure brevity in your answer.  0.87. What is the ratio of the Expenditure(as % of GDP) of Pakistan in 2002 to that in 2009?
Provide a short and direct response. 0.49. What is the ratio of the Expenditure(as % of GDP) of World in 2005 to that in 2007?
Offer a terse response. 1.01. What is the ratio of the Expenditure(as % of GDP) of China in 2005 to that in 2007?
Provide a short and direct response. 0.95. What is the ratio of the Expenditure(as % of GDP) in Pakistan in 2005 to that in 2007?
Offer a very short reply. 0.69. What is the ratio of the Expenditure(as % of GDP) in World in 2005 to that in 2009?
Your answer should be very brief. 0.96. What is the ratio of the Expenditure(as % of GDP) of China in 2005 to that in 2009?
Your answer should be compact. 0.79. What is the ratio of the Expenditure(as % of GDP) in Finland in 2005 to that in 2009?
Your response must be concise. 0.89. What is the ratio of the Expenditure(as % of GDP) of Pakistan in 2005 to that in 2009?
Keep it short and to the point. 0.98. What is the ratio of the Expenditure(as % of GDP) in World in 2007 to that in 2009?
Provide a succinct answer. 0.95. What is the ratio of the Expenditure(as % of GDP) in China in 2007 to that in 2009?
Provide a succinct answer. 0.82. What is the ratio of the Expenditure(as % of GDP) of Finland in 2007 to that in 2009?
Offer a very short reply. 0.89. What is the ratio of the Expenditure(as % of GDP) of Pakistan in 2007 to that in 2009?
Provide a succinct answer. 1.41. What is the difference between the highest and the second highest Expenditure(as % of GDP) in World?
Your answer should be very brief. 0.02. What is the difference between the highest and the second highest Expenditure(as % of GDP) of China?
Provide a succinct answer. 0.29. What is the difference between the highest and the second highest Expenditure(as % of GDP) of Finland?
Offer a very short reply. 0.4. What is the difference between the highest and the second highest Expenditure(as % of GDP) in Pakistan?
Give a very brief answer. 0.18. What is the difference between the highest and the lowest Expenditure(as % of GDP) in World?
Keep it short and to the point. 0.13. What is the difference between the highest and the lowest Expenditure(as % of GDP) of China?
Offer a terse response. 1.03. What is the difference between the highest and the lowest Expenditure(as % of GDP) of Finland?
Your answer should be compact. 0.96. What is the difference between the highest and the lowest Expenditure(as % of GDP) of Pakistan?
Provide a succinct answer. 0.52. 